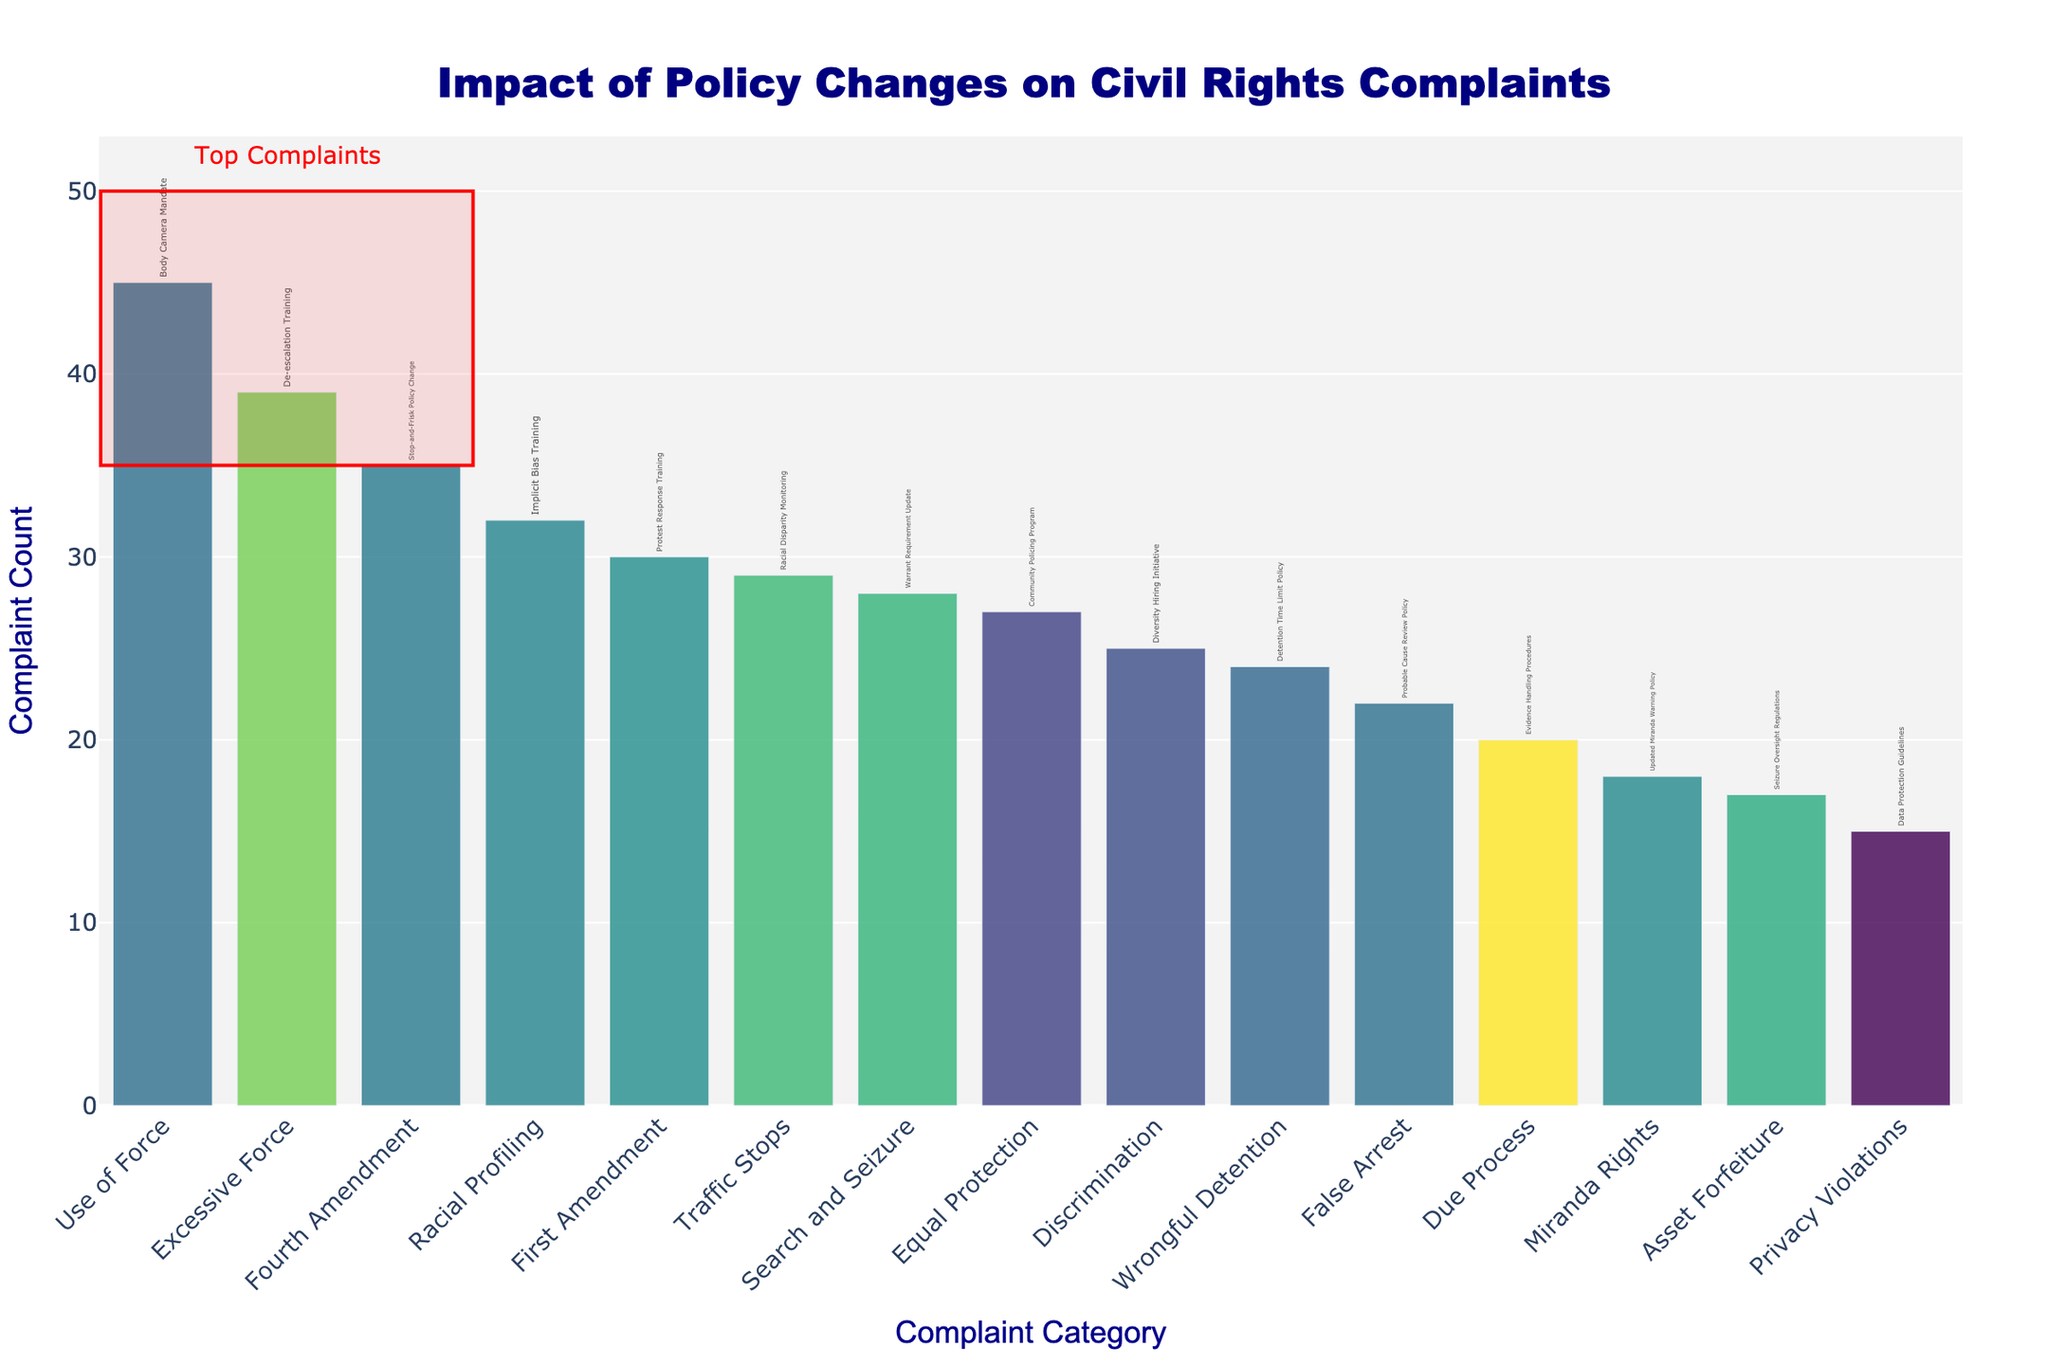What is the title of the plot? The title is presented prominently at the top of the plot. It reads "Impact of Policy Changes on Civil Rights Complaints"
Answer: Impact of Policy Changes on Civil Rights Complaints Which category has the highest number of complaints? The height of the bars represents the number of complaints. The highest bar corresponds to the "Use of Force" category.
Answer: Use of Force How many categories have more than 30 complaints? By scanning the y-axis and counting the bars taller than the 30 mark, we identify "Use of Force," "Racial Profiling," "Excessive Force," and "Fourth Amendment," making a total of four categories.
Answer: 4 What policy change is associated with the "Privacy Violations" category? Hover over the bar labeled "Privacy Violations" or read the text annotations directly to find it is the "Data Protection Guidelines."
Answer: Data Protection Guidelines What is the sum of complaints for "Racial Profiling" and "Search and Seizure"? Extract the values for "Racial Profiling" (32) and "Search and Seizure" (28) and sum them. The total is 32 + 28 = 60.
Answer: 60 Which categories are highlighted as top complaints? The top complaints are enclosed within a red rectangle at the top. These are "Use of Force," "Racial Profiling," and "Excessive Force."
Answer: Use of Force, Racial Profiling, Excessive Force What is the difference in complaint count between "First Amendment" and "Miranda Rights"? Find the values for "First Amendment" (30) and "Miranda Rights" (18), and subtract the latter from the former: 30 - 18 = 12.
Answer: 12 What color scale is used for the bars in the plot? From the legend or color scheme details, it is indicated that the color scale used is 'Viridis'.
Answer: Viridis What category appears third from the left on the x-axis? Counting from the left, the third bar represents "Racial Profiling."
Answer: Racial Profiling Which category associated with "De-escalation Training" has a lower complaint count compared to the "Stop-and-Frisk Policy Change" category? The "De-escalation Training" is linked to the "Excessive Force" with 39 complaints, which is higher than the "Stop-and-Frisk Policy Change" with 35 complaints. By reversing, "Stop-and-Frisk" is the lower category compared to "De-escalation Training."
Answer: Fourth Amendment 